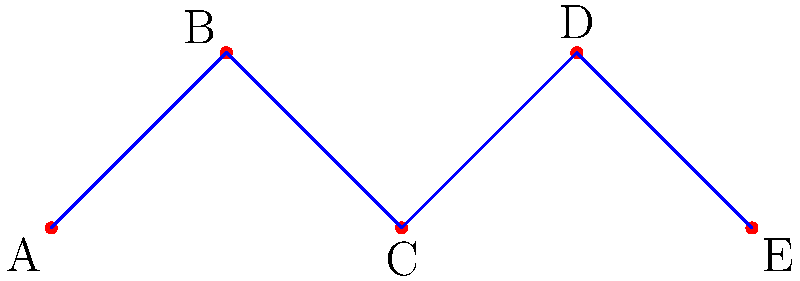In the constellation shown above, which star appears to be the highest in the night sky when viewed from Earth, assuming the diagram represents the constellation as seen directly overhead? To determine which star appears highest in the night sky, we need to consider the vertical position of each star in the diagram:

1. First, identify the vertical positions of each star:
   A: y = 0
   B: y = 1
   C: y = 0
   D: y = 1
   E: y = 0

2. Compare the y-coordinates:
   Stars B and D have the highest y-coordinate (1), while A, C, and E have lower y-coordinates (0).

3. Since both B and D have the same y-coordinate, they appear to be at the same height in the sky.

4. However, the question asks for a single star. In this case, we can consider them equally high.

This question relates to your business perspective as it demonstrates how different positions (like store locations in a pedestrian zone) can affect visibility and potential customer traffic.
Answer: B or D 